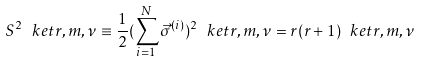<formula> <loc_0><loc_0><loc_500><loc_500>S ^ { 2 } \ k e t { r , m , \nu } \equiv \frac { 1 } { 2 } ( \sum _ { i = 1 } ^ { N } \vec { \sigma } ^ { ( i ) } ) ^ { 2 } \ k e t { r , m , \nu } = r ( r + 1 ) \ k e t { r , m , \nu }</formula> 